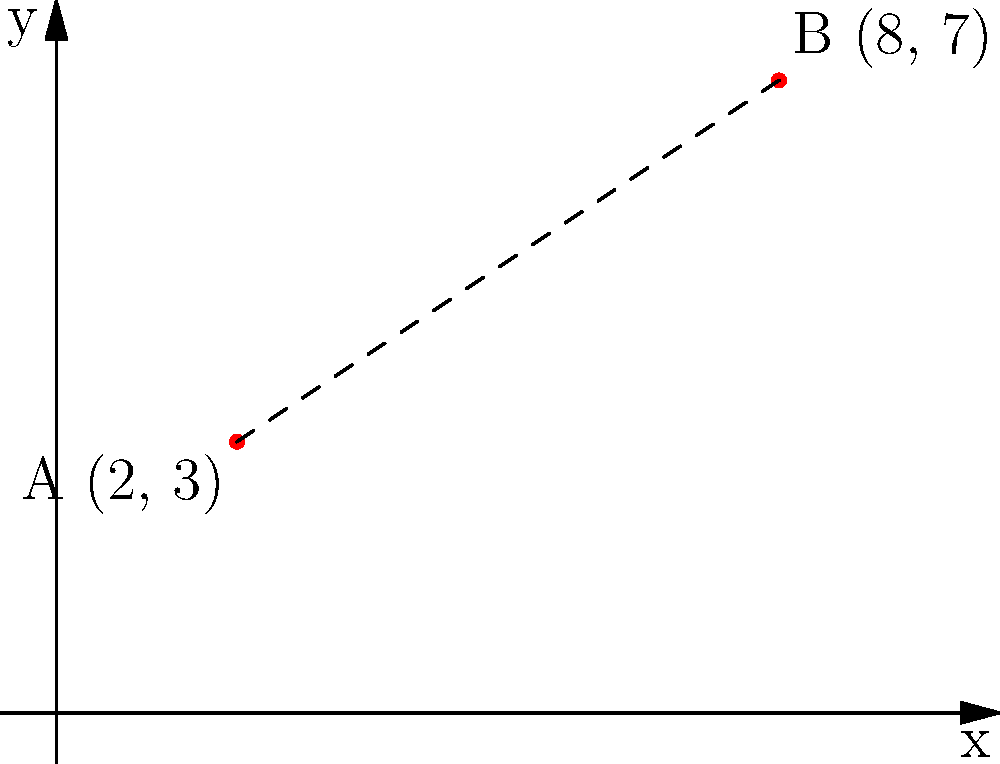As an FSU alumna with an appreciation for historical heritage, imagine you're studying the layout of ancient ruins. Two significant artifacts are located at points A(2, 3) and B(8, 7) on a coordinate plane representing the excavation site. Calculate the distance between these two points to determine the scale of the ruins. Round your answer to two decimal places. To find the distance between two points, we can use the distance formula:

$$ d = \sqrt{(x_2 - x_1)^2 + (y_2 - y_1)^2} $$

Where $(x_1, y_1)$ represents the coordinates of point A, and $(x_2, y_2)$ represents the coordinates of point B.

Step 1: Identify the coordinates
Point A: $(x_1, y_1) = (2, 3)$
Point B: $(x_2, y_2) = (8, 7)$

Step 2: Substitute the values into the distance formula
$$ d = \sqrt{(8 - 2)^2 + (7 - 3)^2} $$

Step 3: Simplify the expressions inside the parentheses
$$ d = \sqrt{6^2 + 4^2} $$

Step 4: Calculate the squares
$$ d = \sqrt{36 + 16} $$

Step 5: Add the values under the square root
$$ d = \sqrt{52} $$

Step 6: Simplify the square root
$$ d = 2\sqrt{13} $$

Step 7: Use a calculator to approximate the value and round to two decimal places
$$ d \approx 7.21 $$

Therefore, the distance between the two artifacts is approximately 7.21 units.
Answer: 7.21 units 